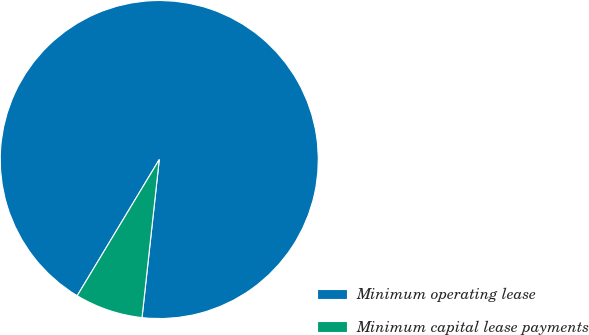Convert chart. <chart><loc_0><loc_0><loc_500><loc_500><pie_chart><fcel>Minimum operating lease<fcel>Minimum capital lease payments<nl><fcel>93.1%<fcel>6.9%<nl></chart> 